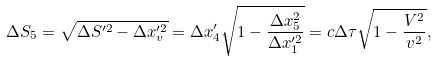Convert formula to latex. <formula><loc_0><loc_0><loc_500><loc_500>\Delta S _ { 5 } = \sqrt { \Delta S ^ { \prime 2 } - \Delta x ^ { \prime 2 } _ { v } } = \Delta x ^ { \prime } _ { 4 } \sqrt { 1 - \frac { \Delta x ^ { 2 } _ { 5 } } { \Delta x ^ { \prime 2 } _ { 1 } } } = c \Delta \tau \sqrt { 1 - \frac { V ^ { 2 } } { v ^ { 2 } } } ,</formula> 